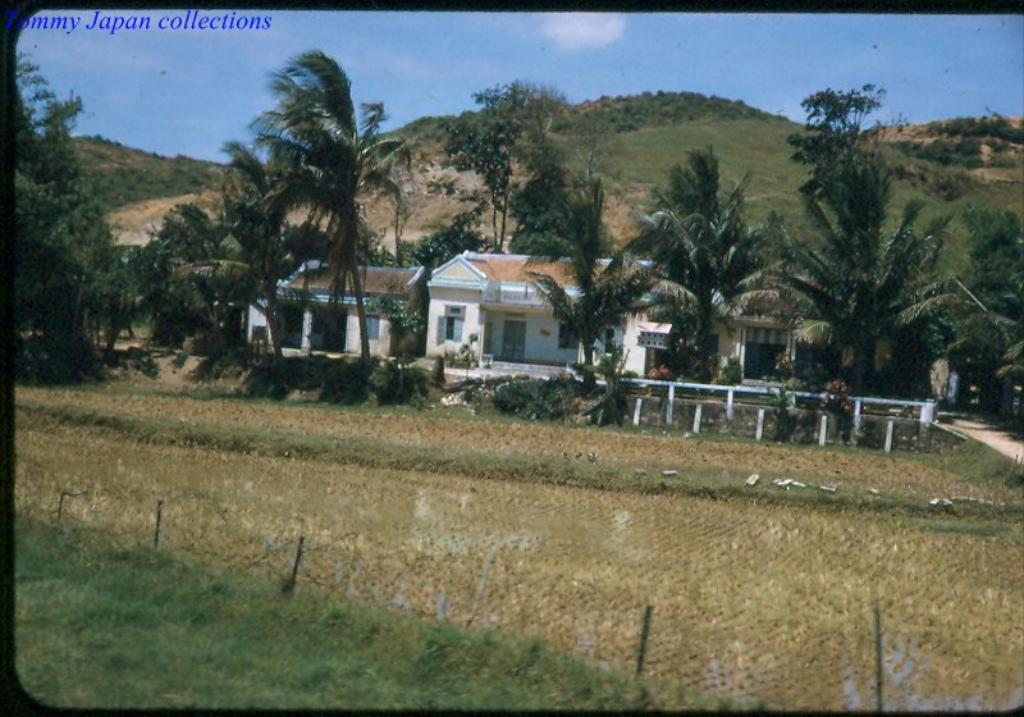Please provide a concise description of this image. In this image, we can see some trees and roof houses. There is a hill in the middle of the image. There is a text in the top left of the image. At the top of the image, we can see the sky. 